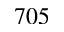Convert formula to latex. <formula><loc_0><loc_0><loc_500><loc_500>7 0 5</formula> 